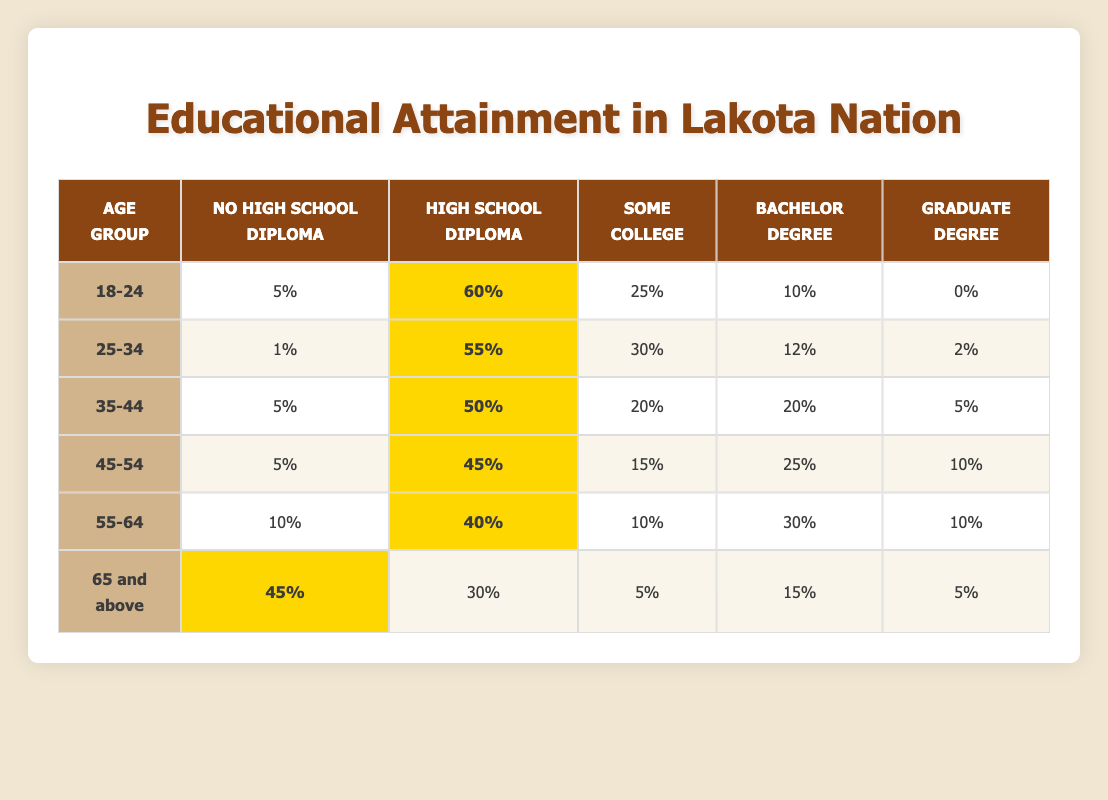What percentage of individuals aged 25-34 have a Bachelor’s Degree? According to the table, 12% of individuals in the 25-34 age group have a Bachelor’s Degree.
Answer: 12% How many individuals aged 45-54 have either a Graduate Degree or a Bachelor’s Degree combined? For the 45-54 age group, 25% have a Bachelor’s Degree and 10% have a Graduate Degree. Adding these percentages together gives 25% + 10% = 35%.
Answer: 35% Is it true that a higher percentage of individuals aged 35-44 have a High School Diploma compared to those aged 55-64? The table shows that 50% of individuals aged 35-44 have a High School Diploma, while only 40% of those aged 55-64 have one. Therefore, the statement is true.
Answer: True What is the average percentage of people with some college education across all age groups? The percentages of some college education are: 25%, 30%, 20%, 15%, 10%, and 5%. Adding these gives 105%, and dividing by the 6 age groups gives an average of 105% / 6 = 17.5%.
Answer: 17.5% Which age group has the highest percentage of individuals without a High School Diploma? The age group "65 and above" has 45% of individuals without a High School Diploma, which is the highest percentage compared to other age groups.
Answer: 65 and above How does the percentage of individuals with a Graduate Degree in the 45-54 age group compare to those in the 18-24 age group? The 45-54 age group has 10% with a Graduate Degree, while the 18-24 age group has 0%. Thus, 10% is greater than 0%.
Answer: 10% is greater than 0% What is the difference in the percentage of individuals with no High School Diploma between the age groups 18-24 and 65 and above? The 18-24 age group has 5%, while the 65 and above group has 45%. The difference is 45% - 5% = 40%.
Answer: 40% Which age group displays the lowest percentage of individuals with a High School Diploma? The age group 65 and above has the lowest percentage of individuals with a High School Diploma at 30%.
Answer: 65 and above If we combine the percentages of individuals who have either a Bachelor’s Degree or a Graduate Degree in the 35-44 age group, what is the total percentage? In the 35-44 age group, 20% have a Bachelor Degree and 5% have a Graduate Degree. Adding these gives 20% + 5% = 25%.
Answer: 25% 